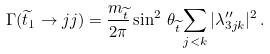Convert formula to latex. <formula><loc_0><loc_0><loc_500><loc_500>\Gamma ( \widetilde { t } _ { 1 } \rightarrow j j ) = \frac { m _ { \widetilde { t } } } { 2 \pi } \sin ^ { 2 } \, \theta _ { \widetilde { t } } \sum _ { j < k } | \lambda ^ { \prime \prime } _ { 3 j k } | ^ { 2 } \, .</formula> 